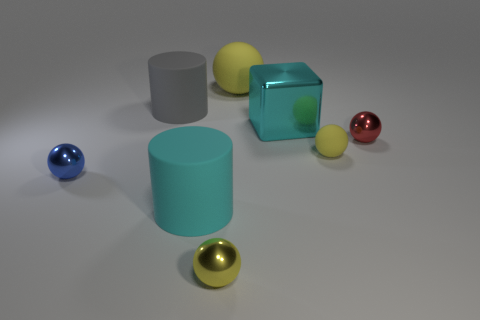Subtract all yellow spheres. How many were subtracted if there are1yellow spheres left? 2 Subtract all brown cubes. How many yellow balls are left? 3 Subtract all tiny blue metal balls. How many balls are left? 4 Subtract all red balls. How many balls are left? 4 Subtract 1 spheres. How many spheres are left? 4 Subtract all purple spheres. Subtract all cyan cubes. How many spheres are left? 5 Add 1 tiny green things. How many objects exist? 9 Subtract 0 purple cylinders. How many objects are left? 8 Subtract all blocks. How many objects are left? 7 Subtract all large matte things. Subtract all large cyan matte cylinders. How many objects are left? 4 